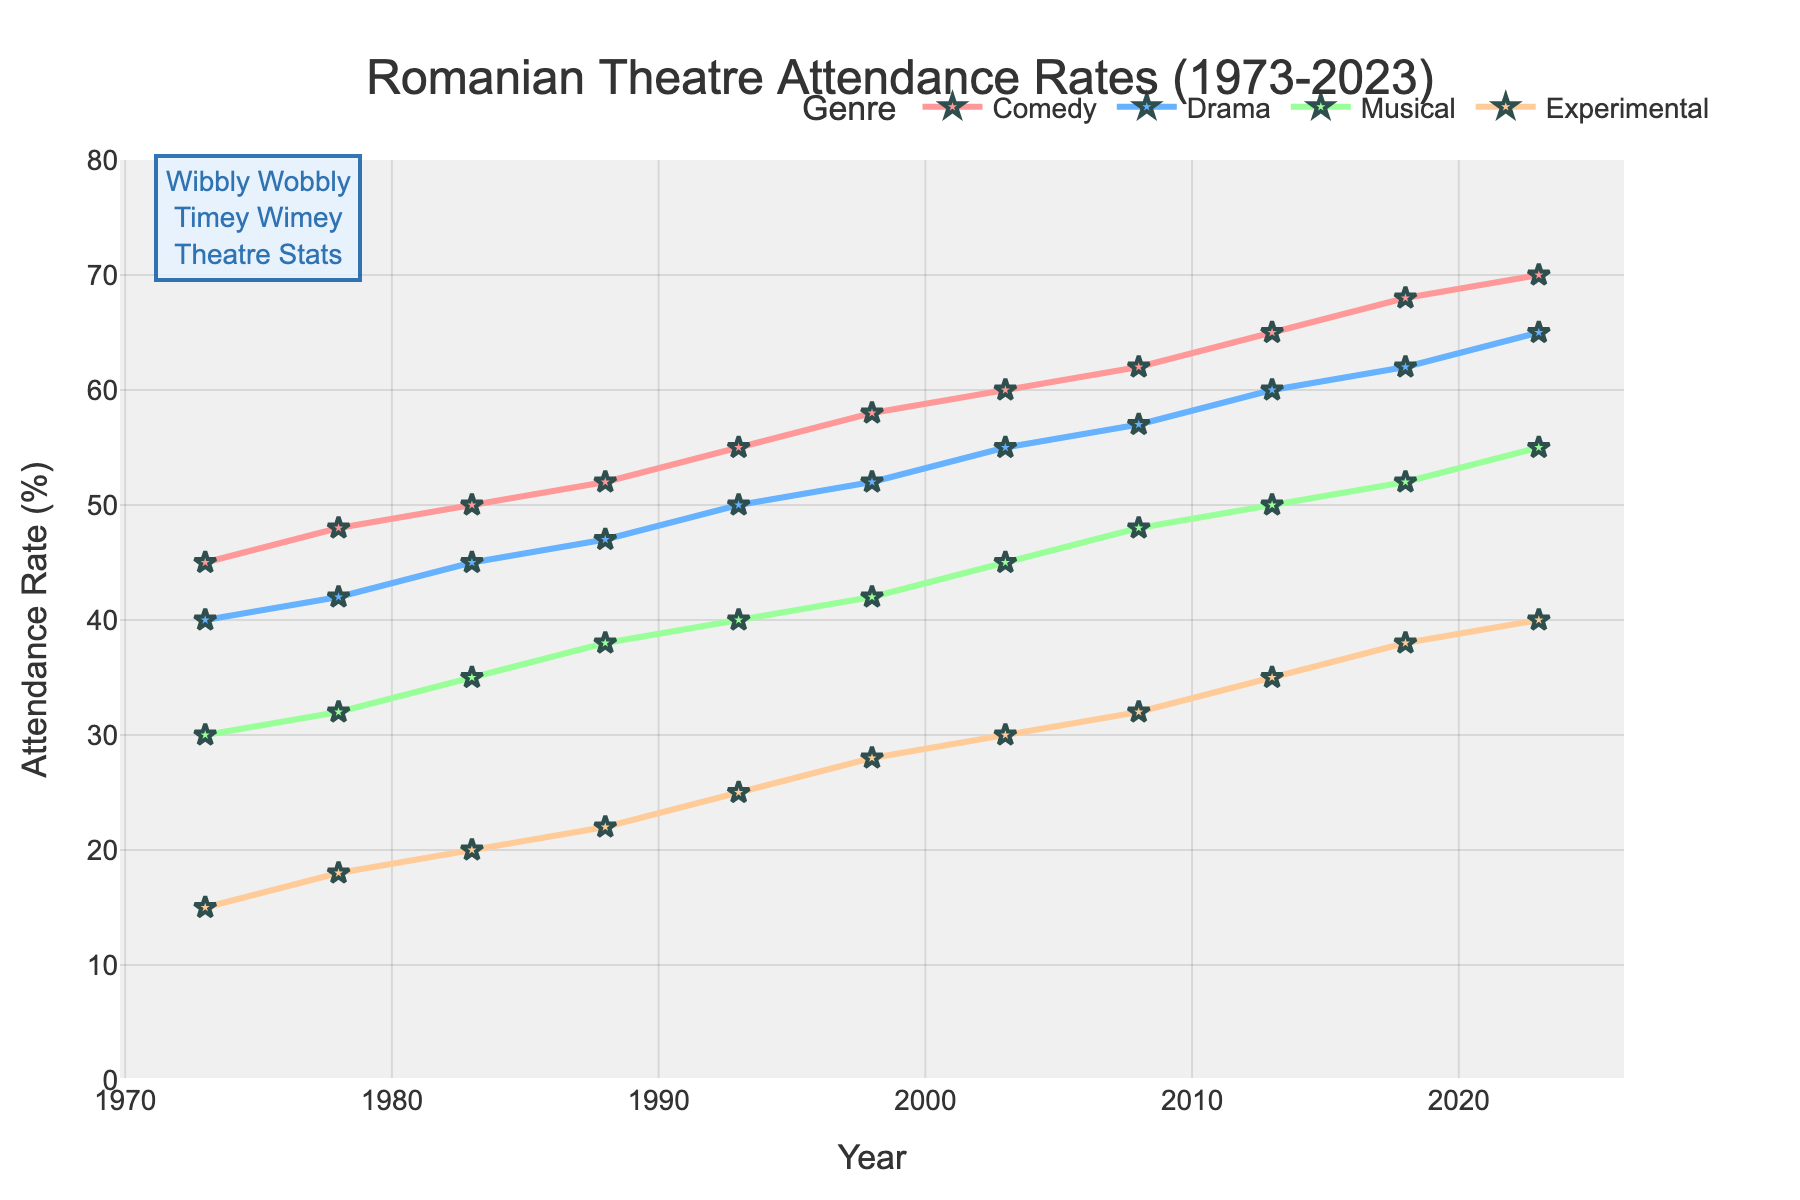Which genre had the highest attendance rate in 2023? To find the highest attendance rate, look for the peak value in 2023. Comedy is the genre with the highest attendance rate of 70%.
Answer: Comedy How did the attendance rate of Musical change from 1973 to 2023? Look at the Musical values in 1973 and 2023. In 1973, the attendance rate was 30%, and it increased to 55% in 2023. Subtract 30% from 55% to find the change, which is 25%.
Answer: Increased by 25% In what year did Drama surpass 50% in attendance rate? Check the Drama values each year and find the first year when it exceeds 50%. Drama attendance rate first surpassed 50% in 2003 with a value of 55%.
Answer: 2003 Which genre showed the most consistent growth over the 50 years? Compare the trends of all genres from 1973 to 2023. Experimental shows more fluctuation than others, while Comedy shows the most consistent, steady upward trend.
Answer: Comedy Compare the attendance rate of Experimental in 1983 and Drama in 1993. Which was higher and by how much? Look at Experimental in 1983 (20%) and Drama in 1993 (50%). Subtract 20% from 50% to get the difference, which is 30%. Drama in 1993 was higher.
Answer: Drama by 30% Calculate the average attendance rate of Comedy over the past 50 years. Sum the Comedy attendance rates for all years: (45+48+50+52+55+58+60+62+65+68+70) = 633. Divide by the number of years (11) to get the average, 57.5%.
Answer: 57.5% Which genre had the lowest attendance rate in 1988, and what was the rate? Look at the values for 1988. Experimental had the lowest attendance rate at 22%.
Answer: Experimental, 22% How much did the attendance rate for Experimental increase between 1973 and 2023? Look at Experimental attendance in 1973 (15%) and in 2023 (40%), subtract 15% from 40%. The difference is 25%.
Answer: Increased by 25% Visualize the color associated with the Drama genre in the chart. Look for the line color representing Drama. The Drama line's color is light blue throughout the chart.
Answer: Light blue 